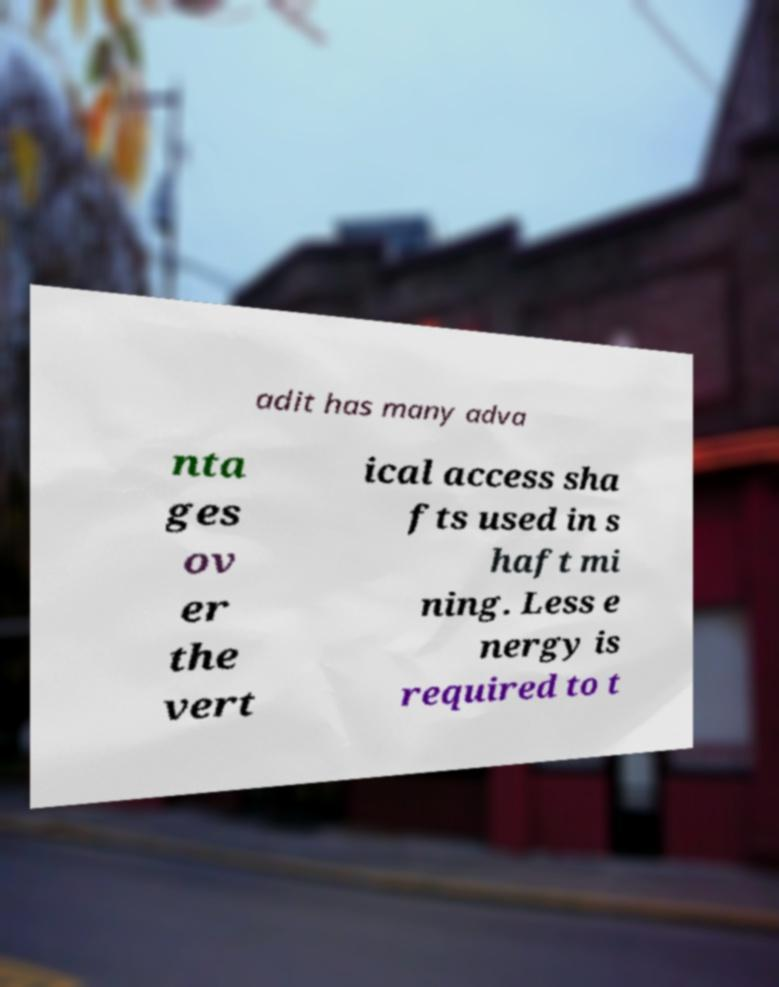Could you assist in decoding the text presented in this image and type it out clearly? adit has many adva nta ges ov er the vert ical access sha fts used in s haft mi ning. Less e nergy is required to t 